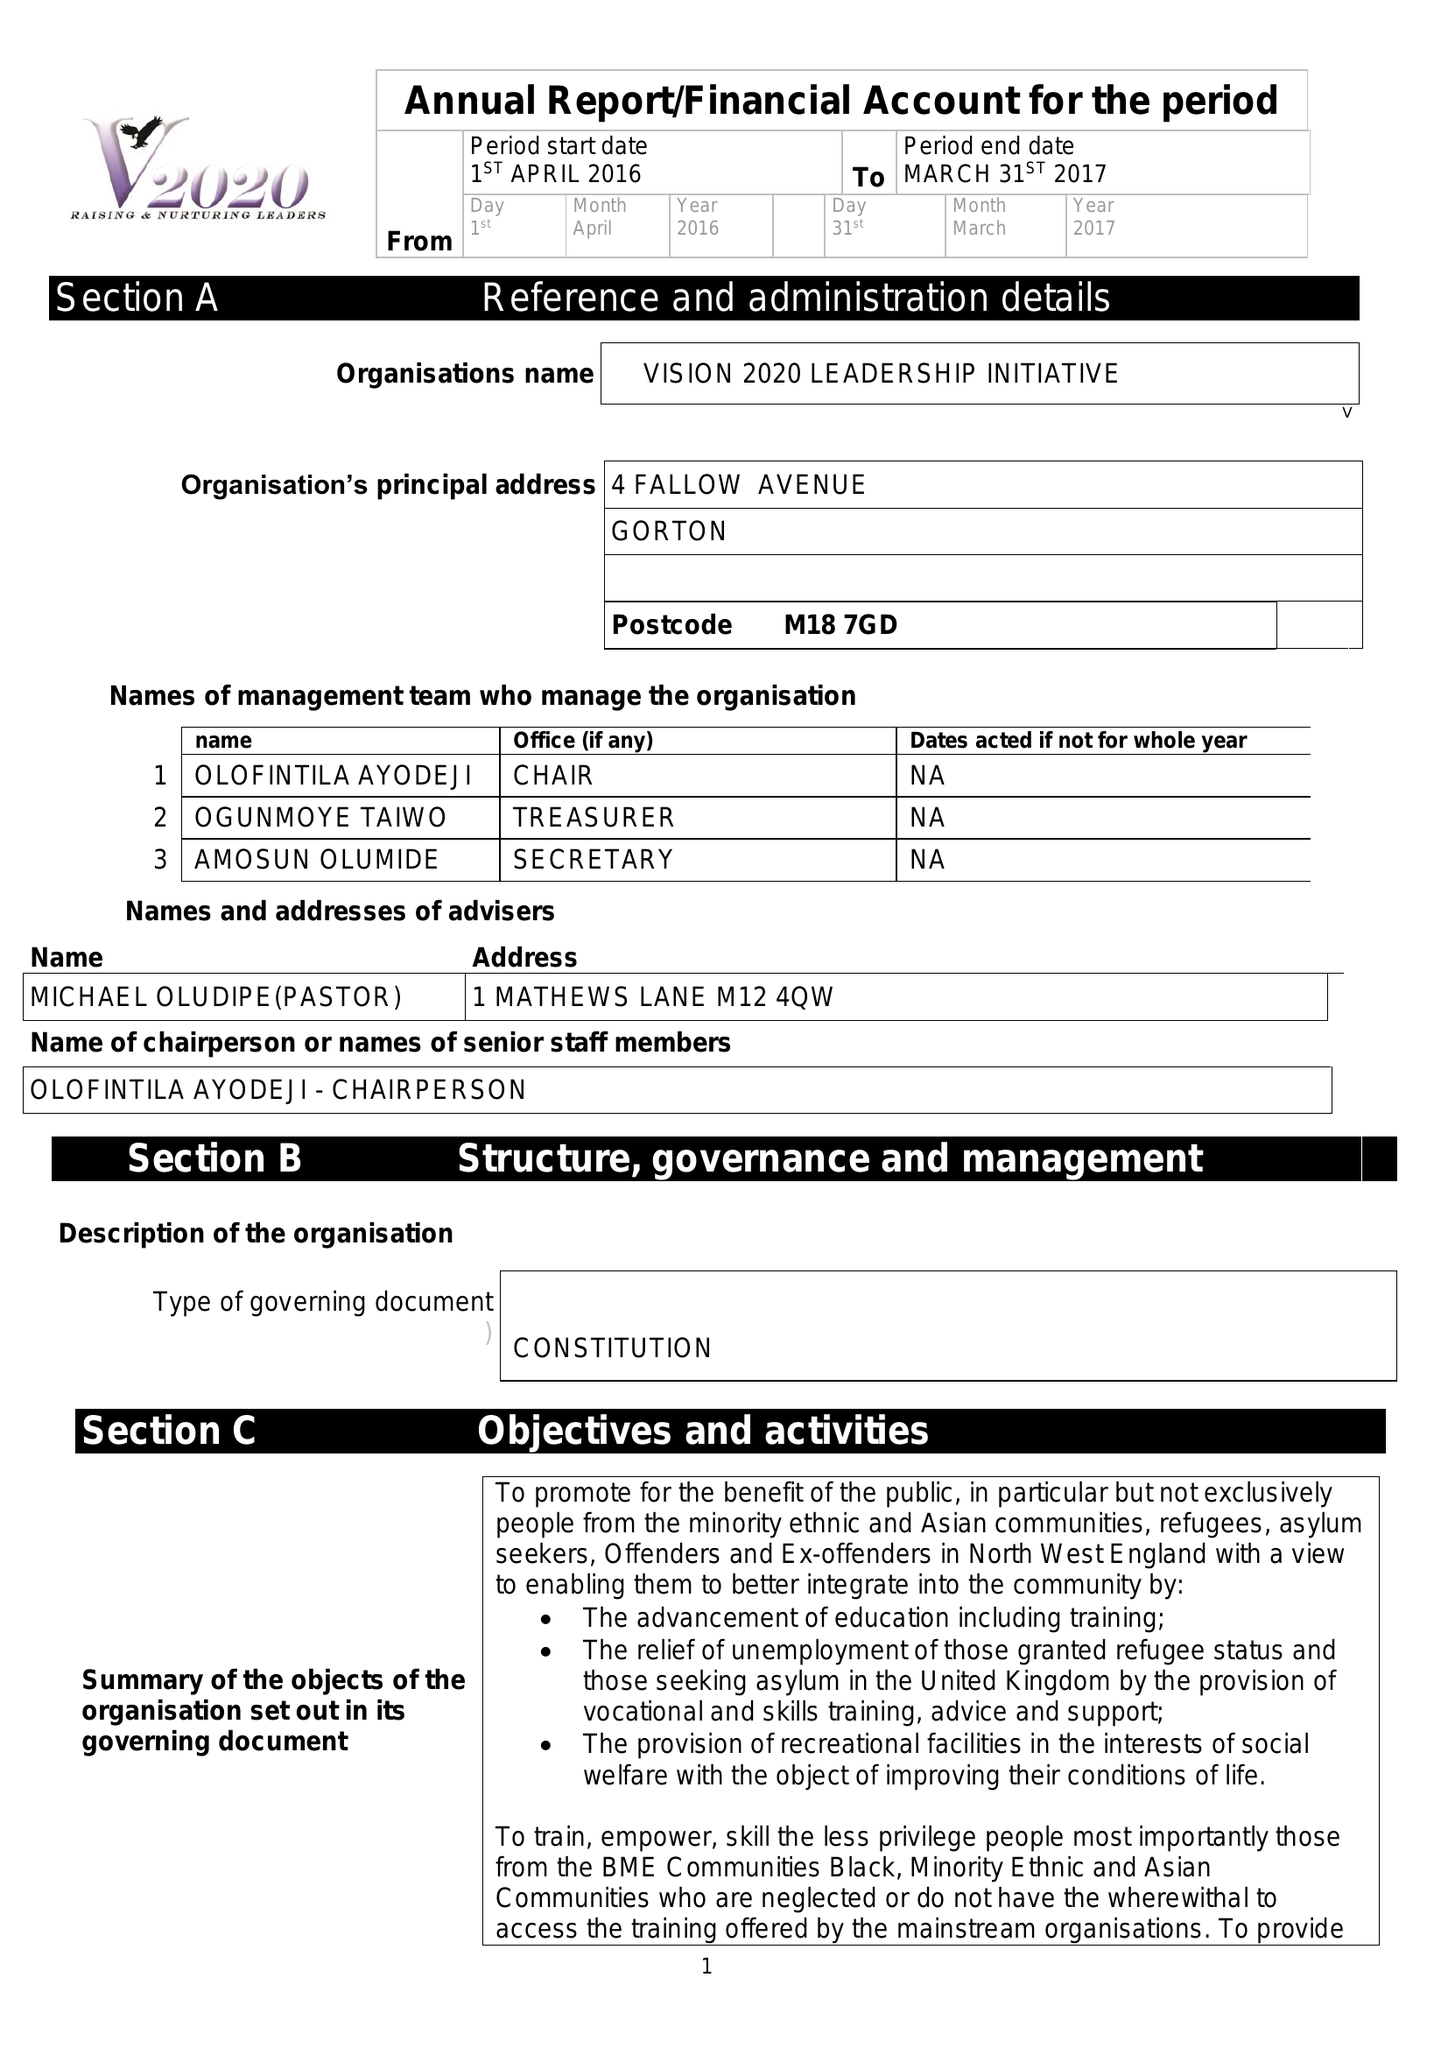What is the value for the spending_annually_in_british_pounds?
Answer the question using a single word or phrase. 50015.00 